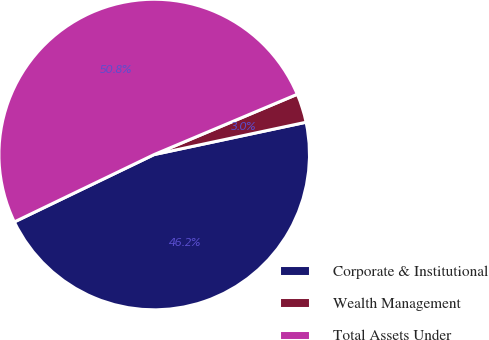Convert chart. <chart><loc_0><loc_0><loc_500><loc_500><pie_chart><fcel>Corporate & Institutional<fcel>Wealth Management<fcel>Total Assets Under<nl><fcel>46.19%<fcel>3.01%<fcel>50.8%<nl></chart> 